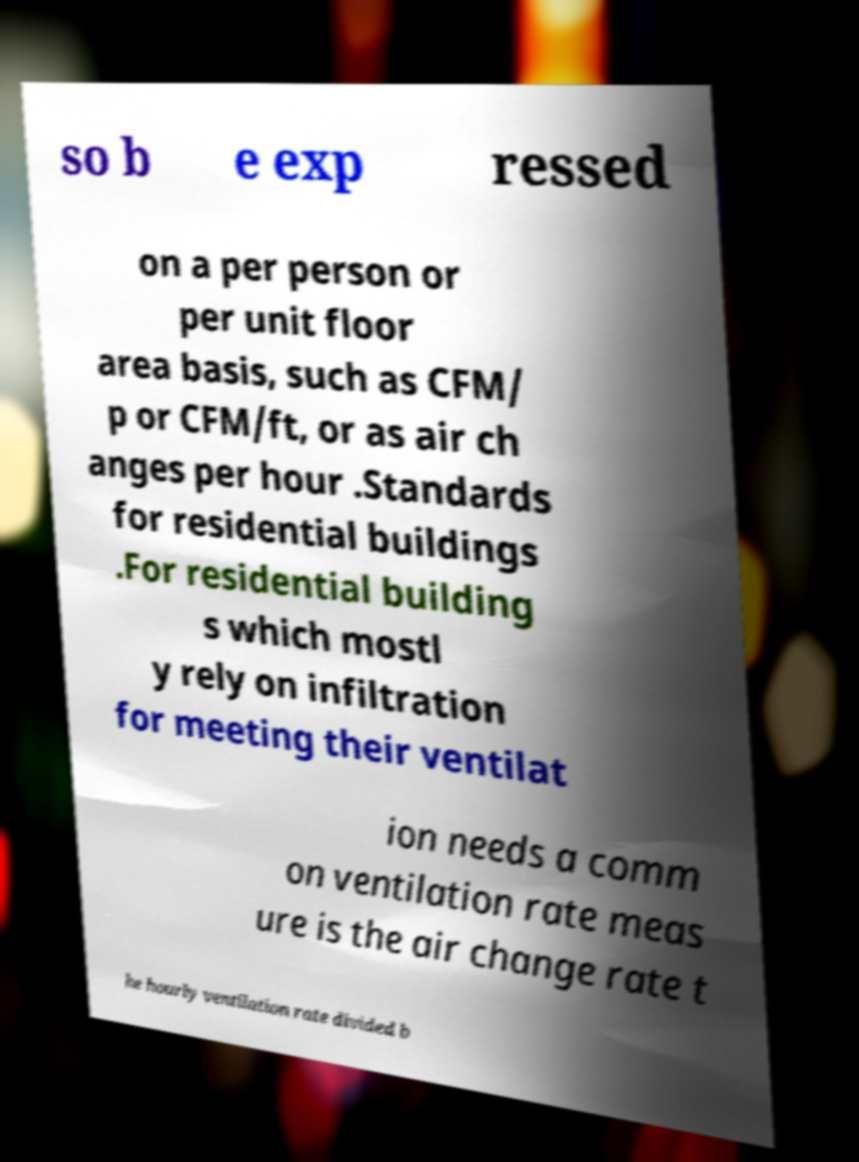What messages or text are displayed in this image? I need them in a readable, typed format. so b e exp ressed on a per person or per unit floor area basis, such as CFM/ p or CFM/ft, or as air ch anges per hour .Standards for residential buildings .For residential building s which mostl y rely on infiltration for meeting their ventilat ion needs a comm on ventilation rate meas ure is the air change rate t he hourly ventilation rate divided b 